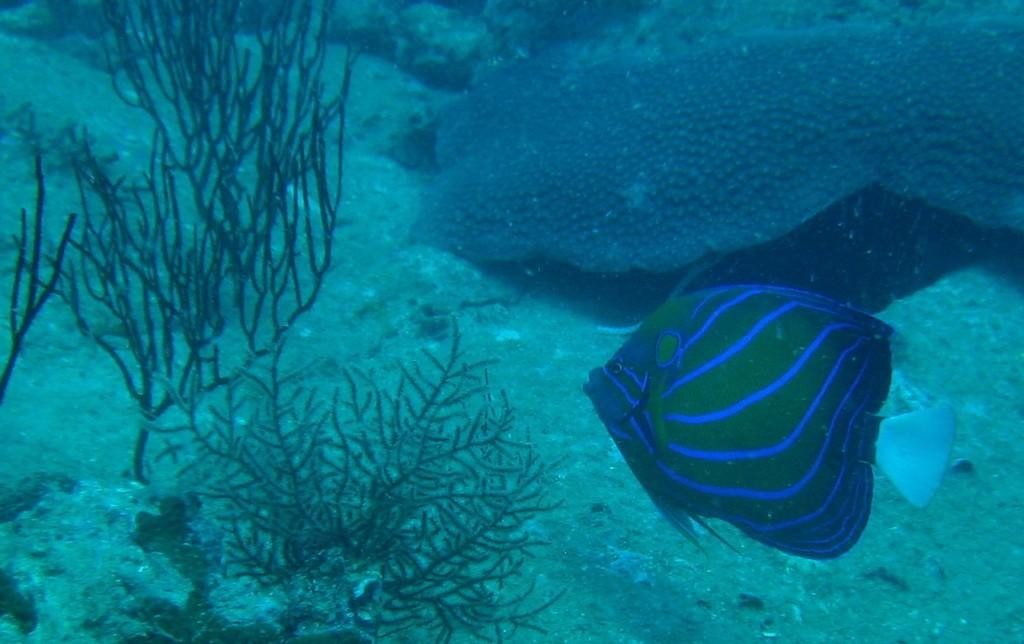What type of animal can be seen on the right side of the image? There is a fish on the right side of the image. What type of vegetation is on the left side of the image? There are water plants on the left side of the image. What type of underwater structures are present in the image? There are corals in the image. What is the primary element visible in the image? There is water visible in the image. What type of corn can be seen growing on the wire in the image? There is no corn or wire present in the image; it features a fish, water plants, corals, and water. 